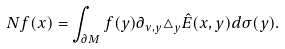<formula> <loc_0><loc_0><loc_500><loc_500>N f ( x ) = \int _ { \partial M } f ( y ) \partial _ { \nu , y } \triangle _ { y } \hat { E } ( x , y ) d \sigma ( y ) .</formula> 